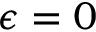<formula> <loc_0><loc_0><loc_500><loc_500>\epsilon = 0</formula> 